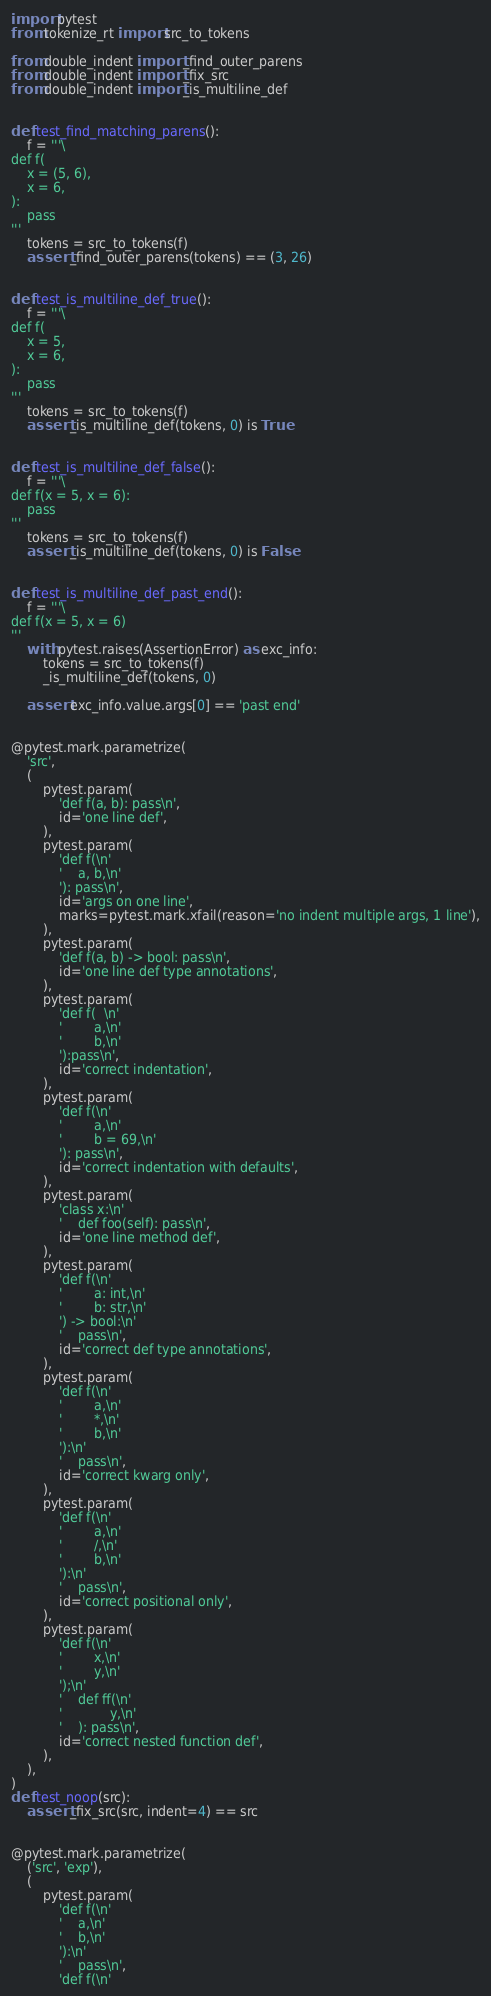<code> <loc_0><loc_0><loc_500><loc_500><_Python_>import pytest
from tokenize_rt import src_to_tokens

from double_indent import _find_outer_parens
from double_indent import _fix_src
from double_indent import _is_multiline_def


def test_find_matching_parens():
    f = '''\
def f(
    x = (5, 6),
    x = 6,
):
    pass
'''
    tokens = src_to_tokens(f)
    assert _find_outer_parens(tokens) == (3, 26)


def test_is_multiline_def_true():
    f = '''\
def f(
    x = 5,
    x = 6,
):
    pass
'''
    tokens = src_to_tokens(f)
    assert _is_multiline_def(tokens, 0) is True


def test_is_multiline_def_false():
    f = '''\
def f(x = 5, x = 6):
    pass
'''
    tokens = src_to_tokens(f)
    assert _is_multiline_def(tokens, 0) is False


def test_is_multiline_def_past_end():
    f = '''\
def f(x = 5, x = 6)
'''
    with pytest.raises(AssertionError) as exc_info:
        tokens = src_to_tokens(f)
        _is_multiline_def(tokens, 0)

    assert exc_info.value.args[0] == 'past end'


@pytest.mark.parametrize(
    'src',
    (
        pytest.param(
            'def f(a, b): pass\n',
            id='one line def',
        ),
        pytest.param(
            'def f(\n'
            '    a, b,\n'
            '): pass\n',
            id='args on one line',
            marks=pytest.mark.xfail(reason='no indent multiple args, 1 line'),
        ),
        pytest.param(
            'def f(a, b) -> bool: pass\n',
            id='one line def type annotations',
        ),
        pytest.param(
            'def f(  \n'
            '        a,\n'
            '        b,\n'
            '):pass\n',
            id='correct indentation',
        ),
        pytest.param(
            'def f(\n'
            '        a,\n'
            '        b = 69,\n'
            '): pass\n',
            id='correct indentation with defaults',
        ),
        pytest.param(
            'class x:\n'
            '    def foo(self): pass\n',
            id='one line method def',
        ),
        pytest.param(
            'def f(\n'
            '        a: int,\n'
            '        b: str,\n'
            ') -> bool:\n'
            '    pass\n',
            id='correct def type annotations',
        ),
        pytest.param(
            'def f(\n'
            '        a,\n'
            '        *,\n'
            '        b,\n'
            '):\n'
            '    pass\n',
            id='correct kwarg only',
        ),
        pytest.param(
            'def f(\n'
            '        a,\n'
            '        /,\n'
            '        b,\n'
            '):\n'
            '    pass\n',
            id='correct positional only',
        ),
        pytest.param(
            'def f(\n'
            '        x,\n'
            '        y,\n'
            ');\n'
            '    def ff(\n'
            '            y,\n'
            '    ): pass\n',
            id='correct nested function def',
        ),
    ),
)
def test_noop(src):
    assert _fix_src(src, indent=4) == src


@pytest.mark.parametrize(
    ('src', 'exp'),
    (
        pytest.param(
            'def f(\n'
            '    a,\n'
            '    b,\n'
            '):\n'
            '    pass\n',
            'def f(\n'</code> 